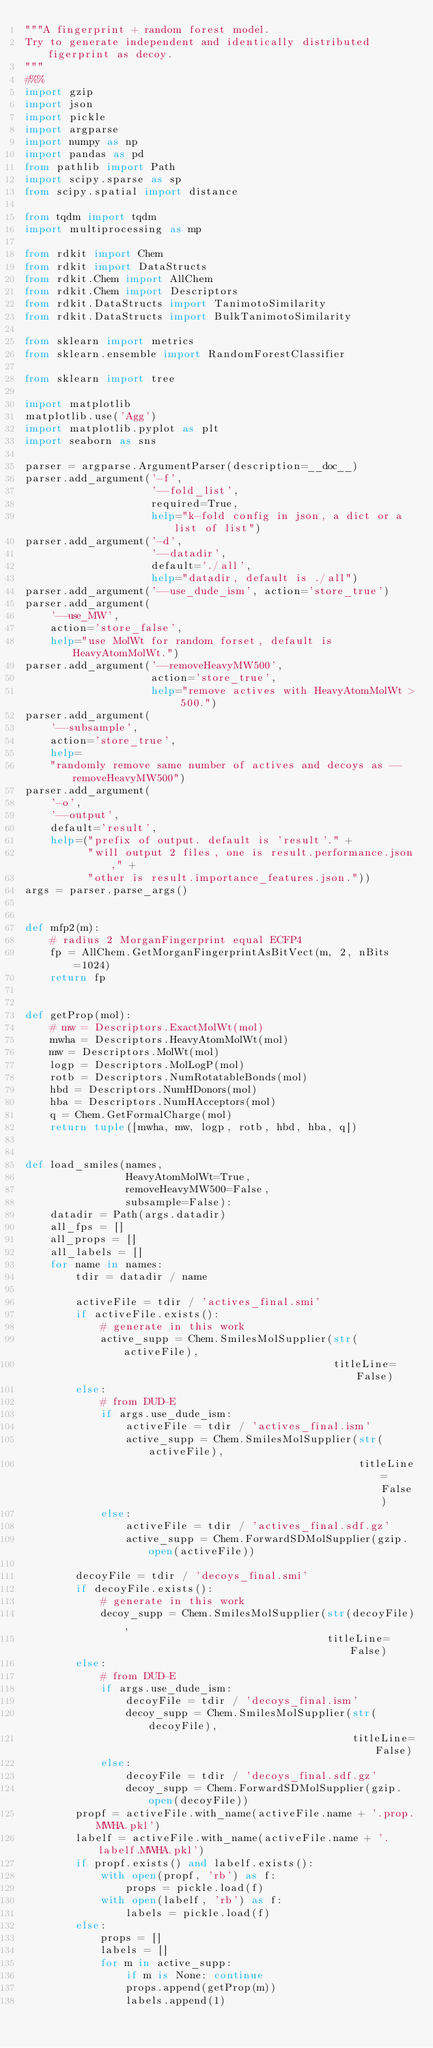<code> <loc_0><loc_0><loc_500><loc_500><_Python_>"""A fingerprint + random forest model.
Try to generate independent and identically distributed figerprint as decoy.
"""
#%%
import gzip
import json
import pickle
import argparse
import numpy as np
import pandas as pd
from pathlib import Path
import scipy.sparse as sp
from scipy.spatial import distance

from tqdm import tqdm
import multiprocessing as mp

from rdkit import Chem
from rdkit import DataStructs
from rdkit.Chem import AllChem
from rdkit.Chem import Descriptors
from rdkit.DataStructs import TanimotoSimilarity
from rdkit.DataStructs import BulkTanimotoSimilarity

from sklearn import metrics
from sklearn.ensemble import RandomForestClassifier

from sklearn import tree

import matplotlib
matplotlib.use('Agg')
import matplotlib.pyplot as plt
import seaborn as sns

parser = argparse.ArgumentParser(description=__doc__)
parser.add_argument('-f',
                    '--fold_list',
                    required=True,
                    help="k-fold config in json, a dict or a list of list")
parser.add_argument('-d',
                    '--datadir',
                    default='./all',
                    help="datadir, default is ./all")
parser.add_argument('--use_dude_ism', action='store_true')
parser.add_argument(
    '--use_MW',
    action='store_false',
    help="use MolWt for random forset, default is HeavyAtomMolWt.")
parser.add_argument('--removeHeavyMW500',
                    action='store_true',
                    help="remove actives with HeavyAtomMolWt > 500.")
parser.add_argument(
    '--subsample',
    action='store_true',
    help=
    "randomly remove same number of actives and decoys as --removeHeavyMW500")
parser.add_argument(
    '-o',
    '--output',
    default='result',
    help=("prefix of output. default is 'result'." +
          "will output 2 files, one is result.performance.json," +
          "other is result.importance_features.json."))
args = parser.parse_args()


def mfp2(m):
    # radius 2 MorganFingerprint equal ECFP4
    fp = AllChem.GetMorganFingerprintAsBitVect(m, 2, nBits=1024)
    return fp


def getProp(mol):
    # mw = Descriptors.ExactMolWt(mol)
    mwha = Descriptors.HeavyAtomMolWt(mol)
    mw = Descriptors.MolWt(mol)
    logp = Descriptors.MolLogP(mol)
    rotb = Descriptors.NumRotatableBonds(mol)
    hbd = Descriptors.NumHDonors(mol)
    hba = Descriptors.NumHAcceptors(mol)
    q = Chem.GetFormalCharge(mol)
    return tuple([mwha, mw, logp, rotb, hbd, hba, q])


def load_smiles(names,
                HeavyAtomMolWt=True,
                removeHeavyMW500=False,
                subsample=False):
    datadir = Path(args.datadir)
    all_fps = []
    all_props = []
    all_labels = []
    for name in names:
        tdir = datadir / name

        activeFile = tdir / 'actives_final.smi'
        if activeFile.exists():
            # generate in this work
            active_supp = Chem.SmilesMolSupplier(str(activeFile),
                                                 titleLine=False)
        else:
            # from DUD-E
            if args.use_dude_ism:
                activeFile = tdir / 'actives_final.ism'
                active_supp = Chem.SmilesMolSupplier(str(activeFile),
                                                     titleLine=False)
            else:
                activeFile = tdir / 'actives_final.sdf.gz'
                active_supp = Chem.ForwardSDMolSupplier(gzip.open(activeFile))

        decoyFile = tdir / 'decoys_final.smi'
        if decoyFile.exists():
            # generate in this work
            decoy_supp = Chem.SmilesMolSupplier(str(decoyFile),
                                                titleLine=False)
        else:
            # from DUD-E
            if args.use_dude_ism:
                decoyFile = tdir / 'decoys_final.ism'
                decoy_supp = Chem.SmilesMolSupplier(str(decoyFile),
                                                    titleLine=False)
            else:
                decoyFile = tdir / 'decoys_final.sdf.gz'
                decoy_supp = Chem.ForwardSDMolSupplier(gzip.open(decoyFile))
        propf = activeFile.with_name(activeFile.name + '.prop.MWHA.pkl')
        labelf = activeFile.with_name(activeFile.name + '.labelf.MWHA.pkl')
        if propf.exists() and labelf.exists():
            with open(propf, 'rb') as f:
                props = pickle.load(f)
            with open(labelf, 'rb') as f:
                labels = pickle.load(f)
        else:
            props = []
            labels = []
            for m in active_supp:
                if m is None: continue
                props.append(getProp(m))
                labels.append(1)</code> 